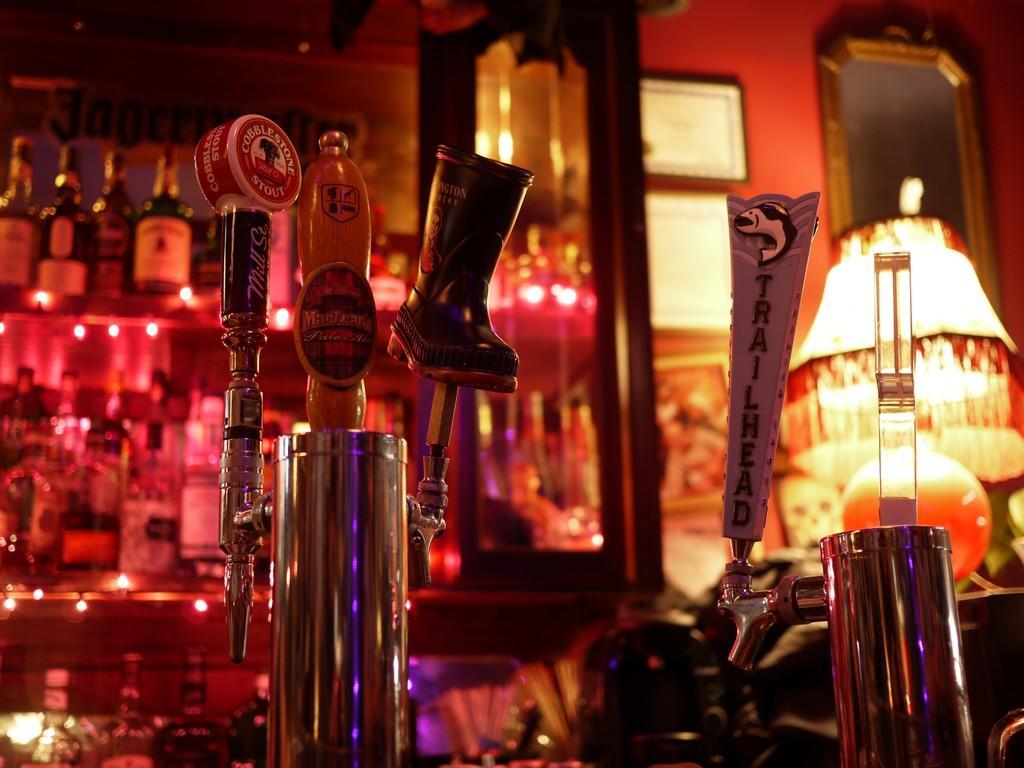Please provide a concise description of this image. In this image, in the middle there is a beer filter with a taps beside it and to the right side there is a lamp and at the background there are wine bottles which are kept on the shelves. To the right bottom there is a filter with a tap. 